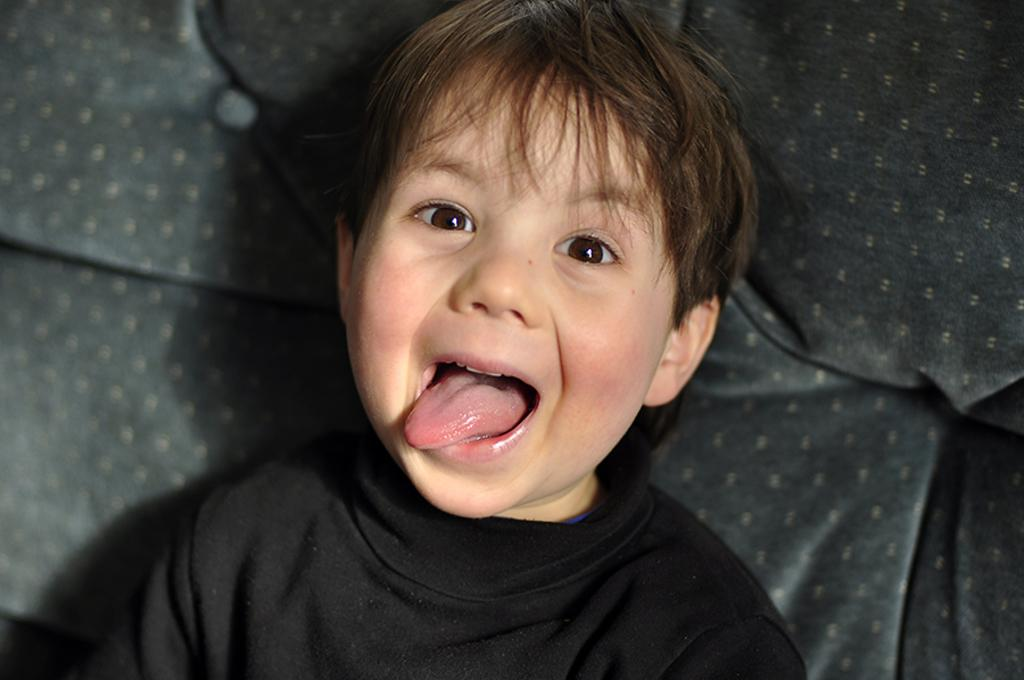What is the main subject of the picture? The main subject of the picture is a boy. What is the boy wearing in the picture? The boy is wearing a black t-shirt. What type of kettle is the boy using during the recess in the image? There is no kettle or recess present in the image; it features a boy wearing a black t-shirt. 